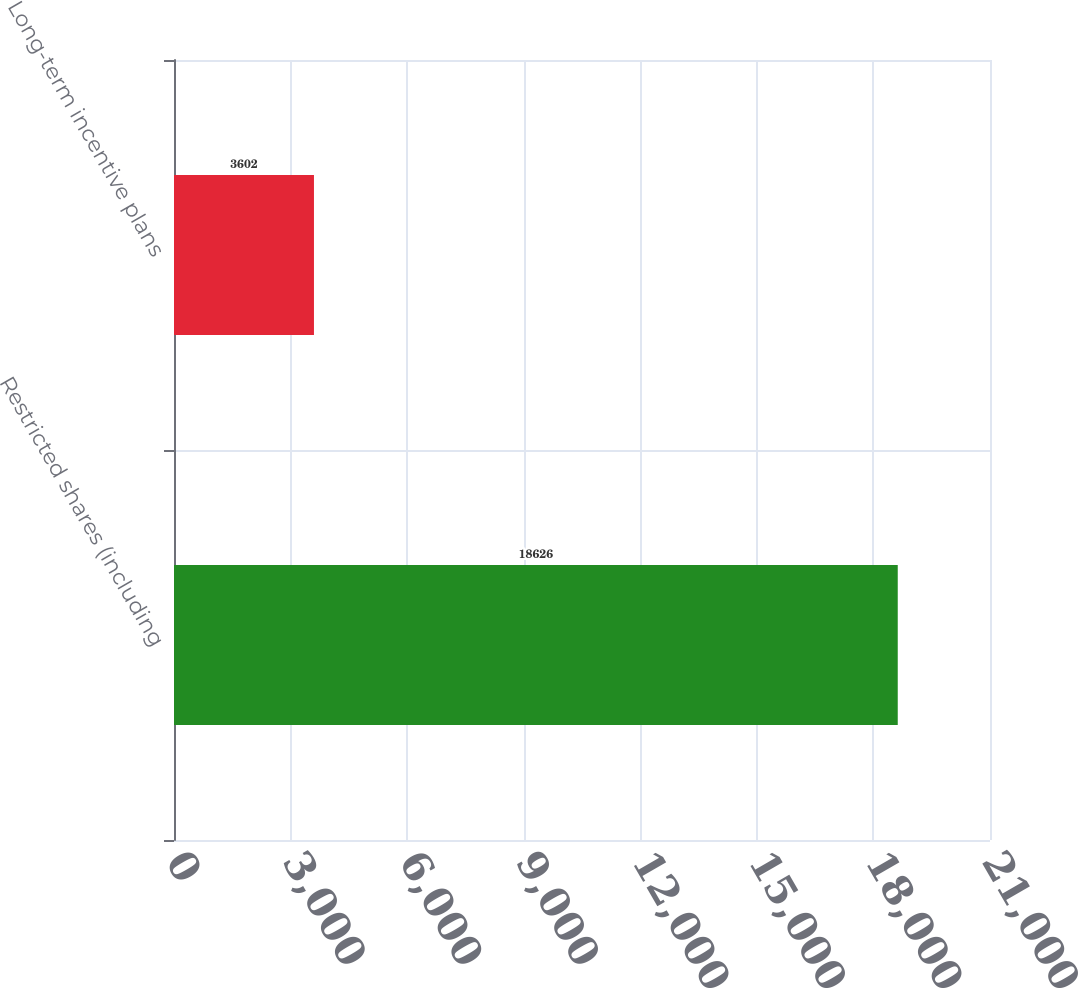<chart> <loc_0><loc_0><loc_500><loc_500><bar_chart><fcel>Restricted shares (including<fcel>Long-term incentive plans<nl><fcel>18626<fcel>3602<nl></chart> 